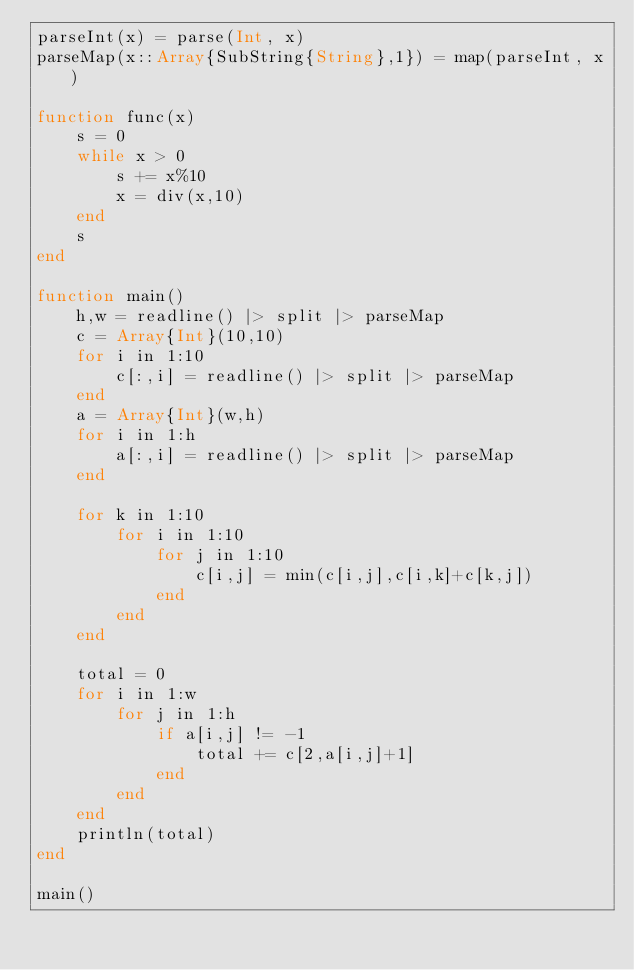Convert code to text. <code><loc_0><loc_0><loc_500><loc_500><_Julia_>parseInt(x) = parse(Int, x)
parseMap(x::Array{SubString{String},1}) = map(parseInt, x)

function func(x)
	s = 0
	while x > 0
		s += x%10
		x = div(x,10)
	end
	s
end

function main()
	h,w = readline() |> split |> parseMap
	c = Array{Int}(10,10)
	for i in 1:10
		c[:,i] = readline() |> split |> parseMap
	end
	a = Array{Int}(w,h)
	for i in 1:h
		a[:,i] = readline() |> split |> parseMap
	end
	
	for k in 1:10
		for i in 1:10
			for j in 1:10
				c[i,j] = min(c[i,j],c[i,k]+c[k,j])
			end
		end
	end
	
	total = 0
	for i in 1:w
		for j in 1:h
			if a[i,j] != -1
				total += c[2,a[i,j]+1]
			end
		end
	end
	println(total)
end

main()
</code> 